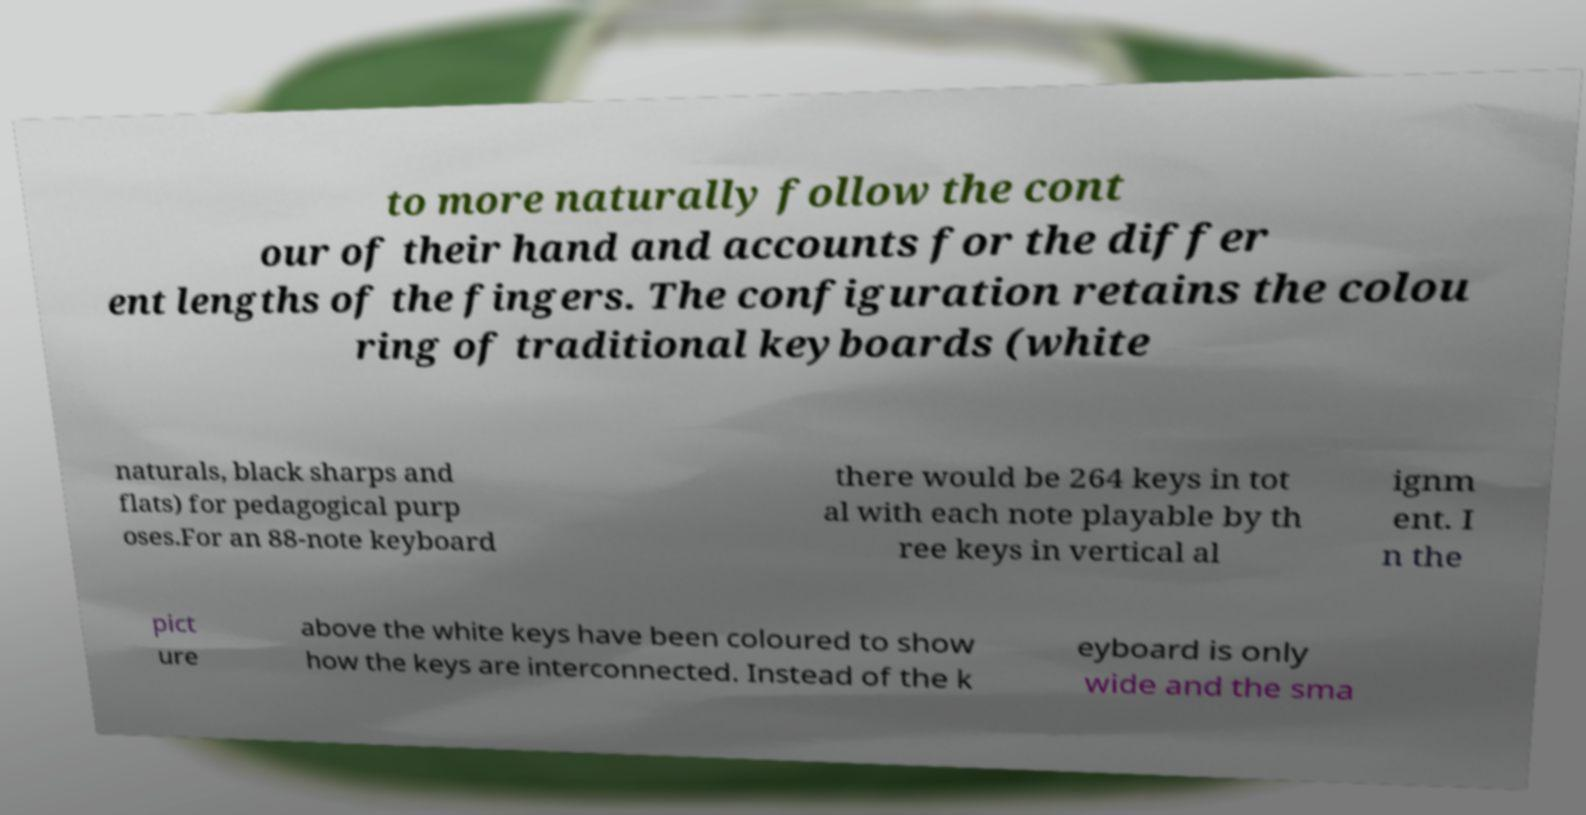Can you read and provide the text displayed in the image?This photo seems to have some interesting text. Can you extract and type it out for me? to more naturally follow the cont our of their hand and accounts for the differ ent lengths of the fingers. The configuration retains the colou ring of traditional keyboards (white naturals, black sharps and flats) for pedagogical purp oses.For an 88-note keyboard there would be 264 keys in tot al with each note playable by th ree keys in vertical al ignm ent. I n the pict ure above the white keys have been coloured to show how the keys are interconnected. Instead of the k eyboard is only wide and the sma 